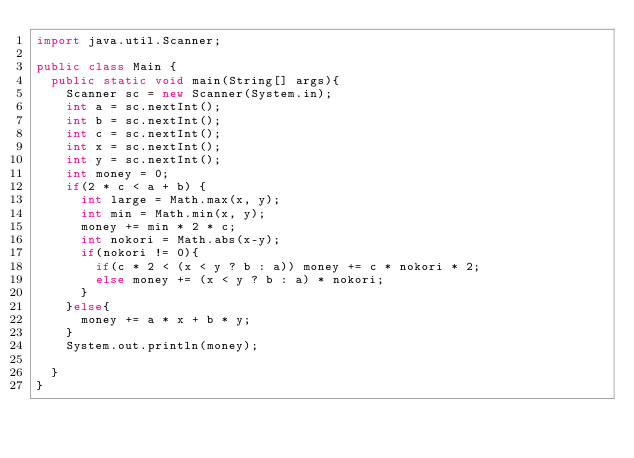<code> <loc_0><loc_0><loc_500><loc_500><_Java_>import java.util.Scanner;

public class Main {
	public static void main(String[] args){
		Scanner sc = new Scanner(System.in);
		int a = sc.nextInt();
		int b = sc.nextInt();
		int c = sc.nextInt();
		int x = sc.nextInt();
		int y = sc.nextInt();
		int money = 0;
		if(2 * c < a + b) {
			int large = Math.max(x, y);
			int min = Math.min(x, y);
			money += min * 2 * c;
			int nokori = Math.abs(x-y);
			if(nokori != 0){
				if(c * 2 < (x < y ? b : a)) money += c * nokori * 2;
				else money += (x < y ? b : a) * nokori;
			}
		}else{
			money += a * x + b * y;
		}
		System.out.println(money);

	}
}</code> 